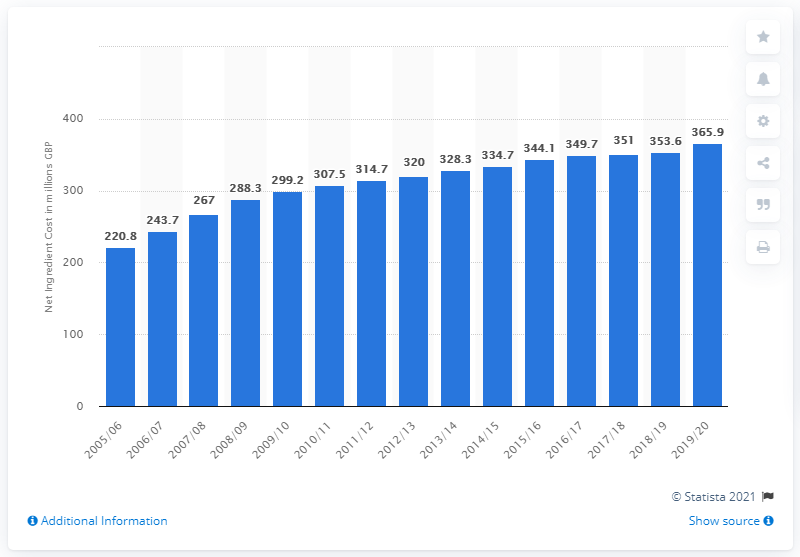Give some essential details in this illustration. The net ingredient cost for insulins used to treat diabetes increased from 2005/2006. In 2019/20, the NIC for insulins was 365.9%. 